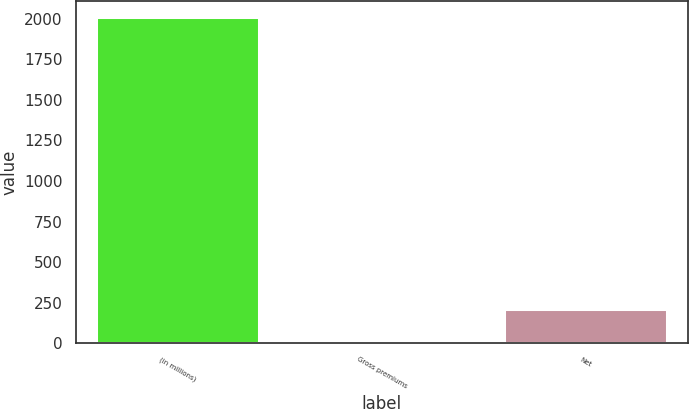Convert chart to OTSL. <chart><loc_0><loc_0><loc_500><loc_500><bar_chart><fcel>(in millions)<fcel>Gross premiums<fcel>Net<nl><fcel>2012<fcel>11<fcel>211.1<nl></chart> 